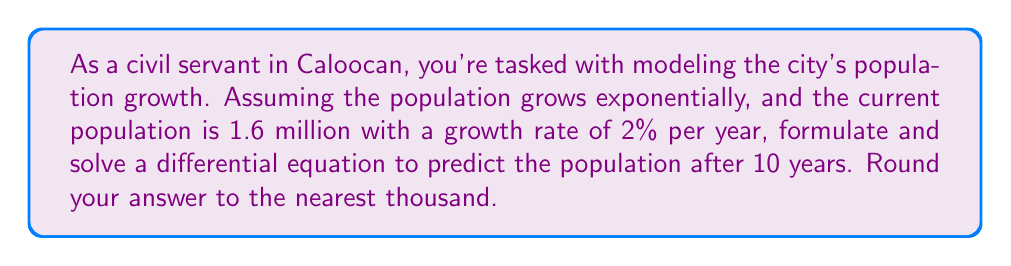Give your solution to this math problem. Let's approach this step-by-step:

1) Let $P(t)$ be the population at time $t$ in years, with $t=0$ representing the current year.

2) The differential equation for exponential growth is:

   $$\frac{dP}{dt} = kP$$

   where $k$ is the growth rate constant.

3) We're given that the growth rate is 2% per year, so $k = 0.02$.

4) The initial condition is $P(0) = 1.6$ million.

5) Our differential equation with initial condition is:

   $$\frac{dP}{dt} = 0.02P, \quad P(0) = 1.6$$

6) To solve this, we separate variables:

   $$\frac{dP}{P} = 0.02dt$$

7) Integrate both sides:

   $$\int \frac{dP}{P} = \int 0.02dt$$
   
   $$\ln|P| = 0.02t + C$$

8) Solve for $P$:

   $$P = e^{0.02t + C} = e^C \cdot e^{0.02t}$$

9) Use the initial condition to find $e^C$:

   $$1.6 = e^C \cdot e^{0.02 \cdot 0} = e^C$$

10) Therefore, our solution is:

    $$P(t) = 1.6 \cdot e^{0.02t}$$

11) To find the population after 10 years, we calculate $P(10)$:

    $$P(10) = 1.6 \cdot e^{0.02 \cdot 10} = 1.6 \cdot e^{0.2} \approx 1.951976$$

12) Rounding to the nearest thousand:

    $$P(10) \approx 1,952,000$$
Answer: The predicted population of Caloocan after 10 years is approximately 1,952,000. 